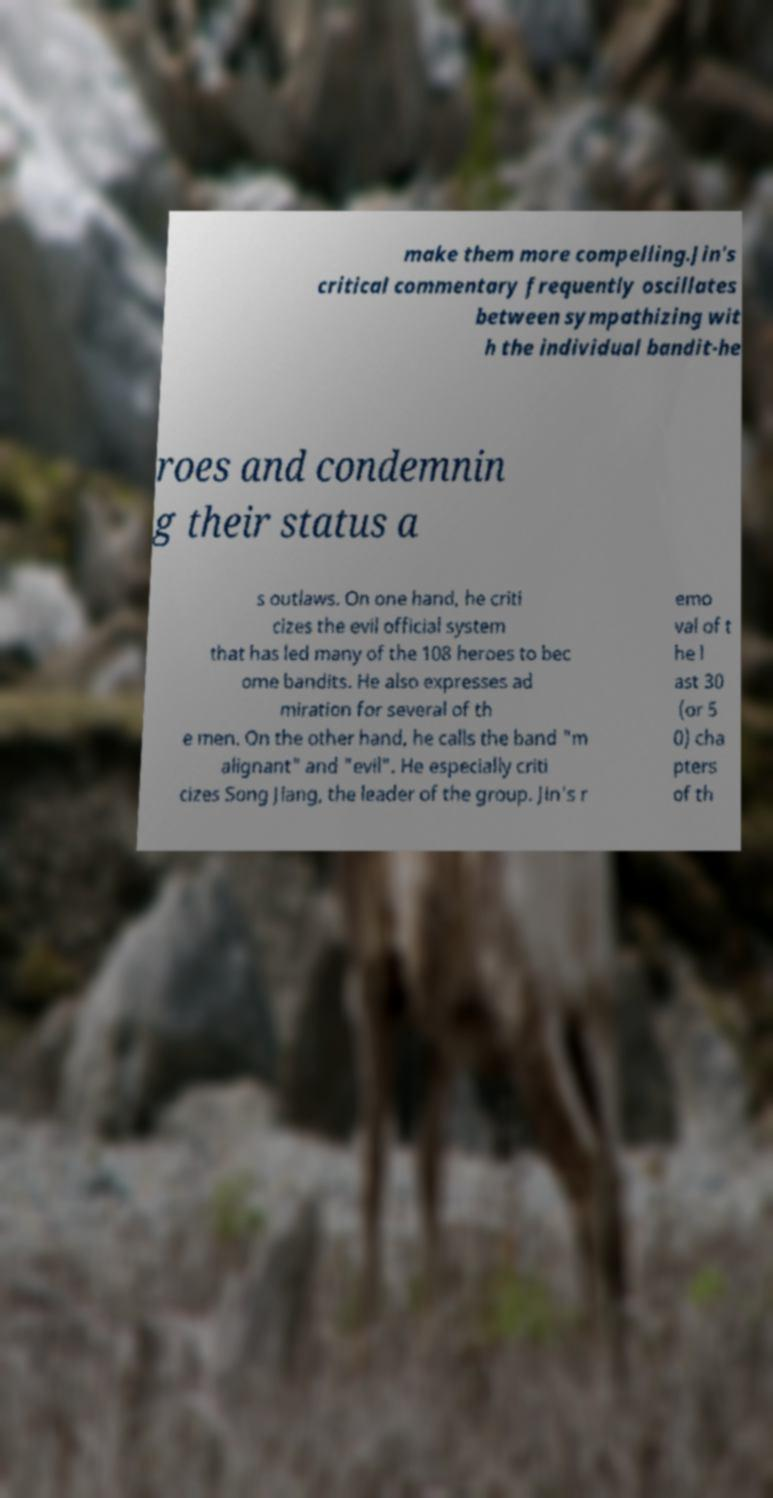Please read and relay the text visible in this image. What does it say? make them more compelling.Jin's critical commentary frequently oscillates between sympathizing wit h the individual bandit-he roes and condemnin g their status a s outlaws. On one hand, he criti cizes the evil official system that has led many of the 108 heroes to bec ome bandits. He also expresses ad miration for several of th e men. On the other hand, he calls the band "m alignant" and "evil". He especially criti cizes Song Jiang, the leader of the group. Jin's r emo val of t he l ast 30 (or 5 0) cha pters of th 